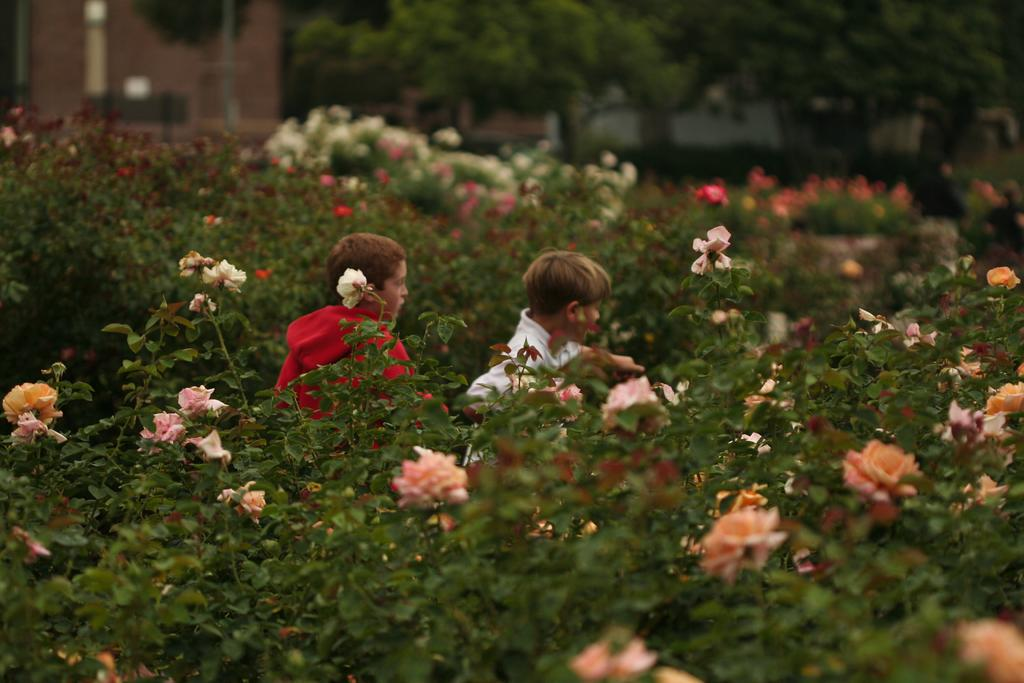How many kids are in the image? There are two kids in the image. What is located at the bottom of the image? There are flowers at the bottom of the image. What are the flowers associated with? The flowers are associated with plants. What can be seen at the top of the image? There are trees, buildings, and a pole at the top of the image. What type of pen is the kid holding in the image? There is no pen present in the image; the kids are not holding any writing instruments. 